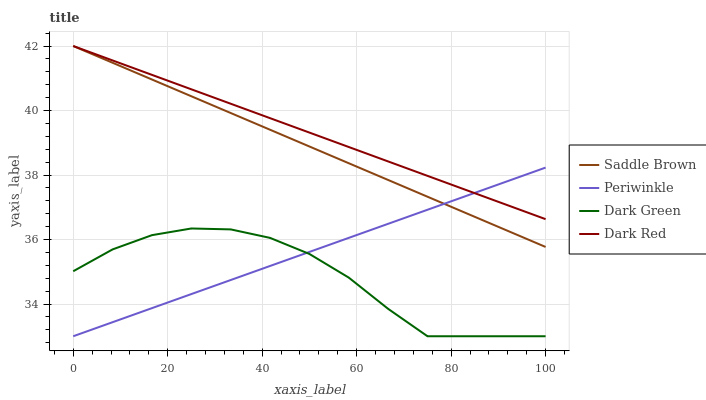Does Periwinkle have the minimum area under the curve?
Answer yes or no. No. Does Periwinkle have the maximum area under the curve?
Answer yes or no. No. Is Periwinkle the smoothest?
Answer yes or no. No. Is Periwinkle the roughest?
Answer yes or no. No. Does Saddle Brown have the lowest value?
Answer yes or no. No. Does Periwinkle have the highest value?
Answer yes or no. No. Is Dark Green less than Saddle Brown?
Answer yes or no. Yes. Is Saddle Brown greater than Dark Green?
Answer yes or no. Yes. Does Dark Green intersect Saddle Brown?
Answer yes or no. No. 